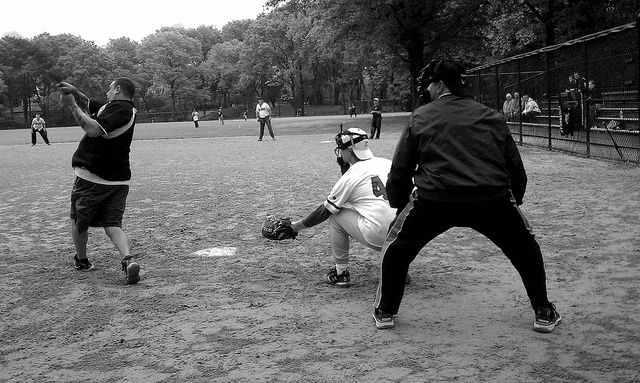Describe the objects in this image and their specific colors. I can see people in white, black, gray, darkgray, and lightgray tones, people in white, black, gray, darkgray, and lightgray tones, people in white, darkgray, gray, and black tones, baseball glove in white, black, gray, darkgray, and lightgray tones, and people in white, black, gray, darkgray, and lightgray tones in this image. 